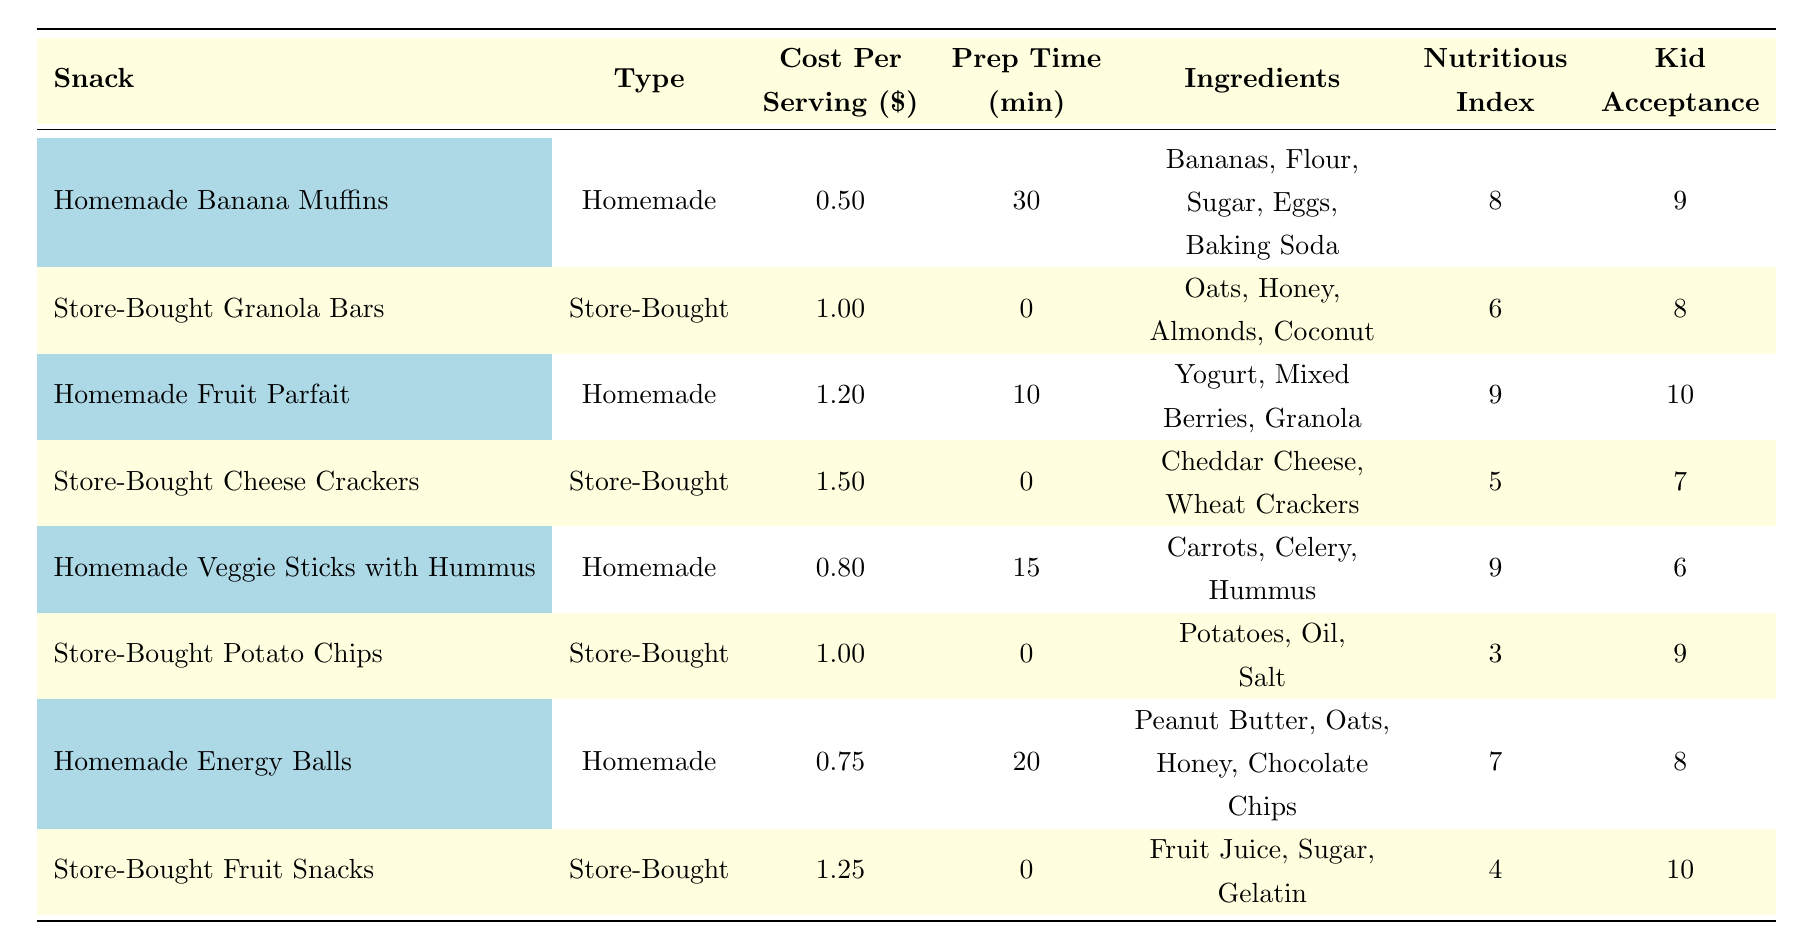What is the cost per serving of Homemade Banana Muffins? The table shows that the cost per serving of Homemade Banana Muffins is listed directly under the "Cost Per Serving" column, which states 0.50.
Answer: 0.50 What is the preparation time for Store-Bought Cheese Crackers? According to the table, the preparation time for Store-Bought Cheese Crackers is found in the "Prep Time" column, which shows 0 minutes.
Answer: 0 Which homemade snack has the highest Kid Acceptance Score? Looking at the "Kid Acceptance" column, the snacks are ranked for acceptance. The Homemade Fruit Parfait scores a perfect 10, making it the highest in this column.
Answer: Homemade Fruit Parfait Is the Total Cost per Serving of Store-Bought Granola Bars higher than that of Homemade Energy Balls? The cost per serving for Store-Bought Granola Bars is 1.00, while the cost for Homemade Energy Balls is 0.75. Since 1.00 is greater than 0.75, the statement is true.
Answer: Yes What is the average preparation time for all the homemade snacks? The preparation times for homemade snacks are 30, 10, 15, and 20 minutes. Summing these gives 30 + 10 + 15 + 20 = 75 minutes. There are 4 homemade snacks, so the average preparation time is 75/4 = 18.75 minutes.
Answer: 18.75 Is the Nutritious Index of Store-Bought Potato Chips greater than the Nutritious Index of Homemade Veggie Sticks with Hummus? The Nutritious Index of Store-Bought Potato Chips is 3, while that of Homemade Veggie Sticks is 9. Since 3 is less than 9, the statement is false.
Answer: No What is the total cost per serving for all the snacks? The total cost per serving can be calculated by adding all the costs listed: 0.50 + 1.00 + 1.20 + 1.50 + 0.80 + 1.00 + 0.75 + 1.25 = 7.00. Thus, the total cost is 7.00.
Answer: 7.00 Are there more Store-Bought snacks than Homemade snacks listed in the table? The table contains 4 Homemade snacks and 4 Store-Bought snacks. Since the counts are equal, the statement is false.
Answer: No Which type of snack has a higher average Nutritious Index: Homemade or Store-Bought? The Nutritious Indices for Homemade snacks are 8, 9, 9, and 7, which sum to 33. The average is 33 / 4 = 8.25. Store-Bought snacks have indices of 6, 5, 3, and 4, summing to 18, giving an average of 18 / 4 = 4.5. Since 8.25 is greater than 4.5, Homemade snacks have a higher average Nutritious Index.
Answer: Homemade 